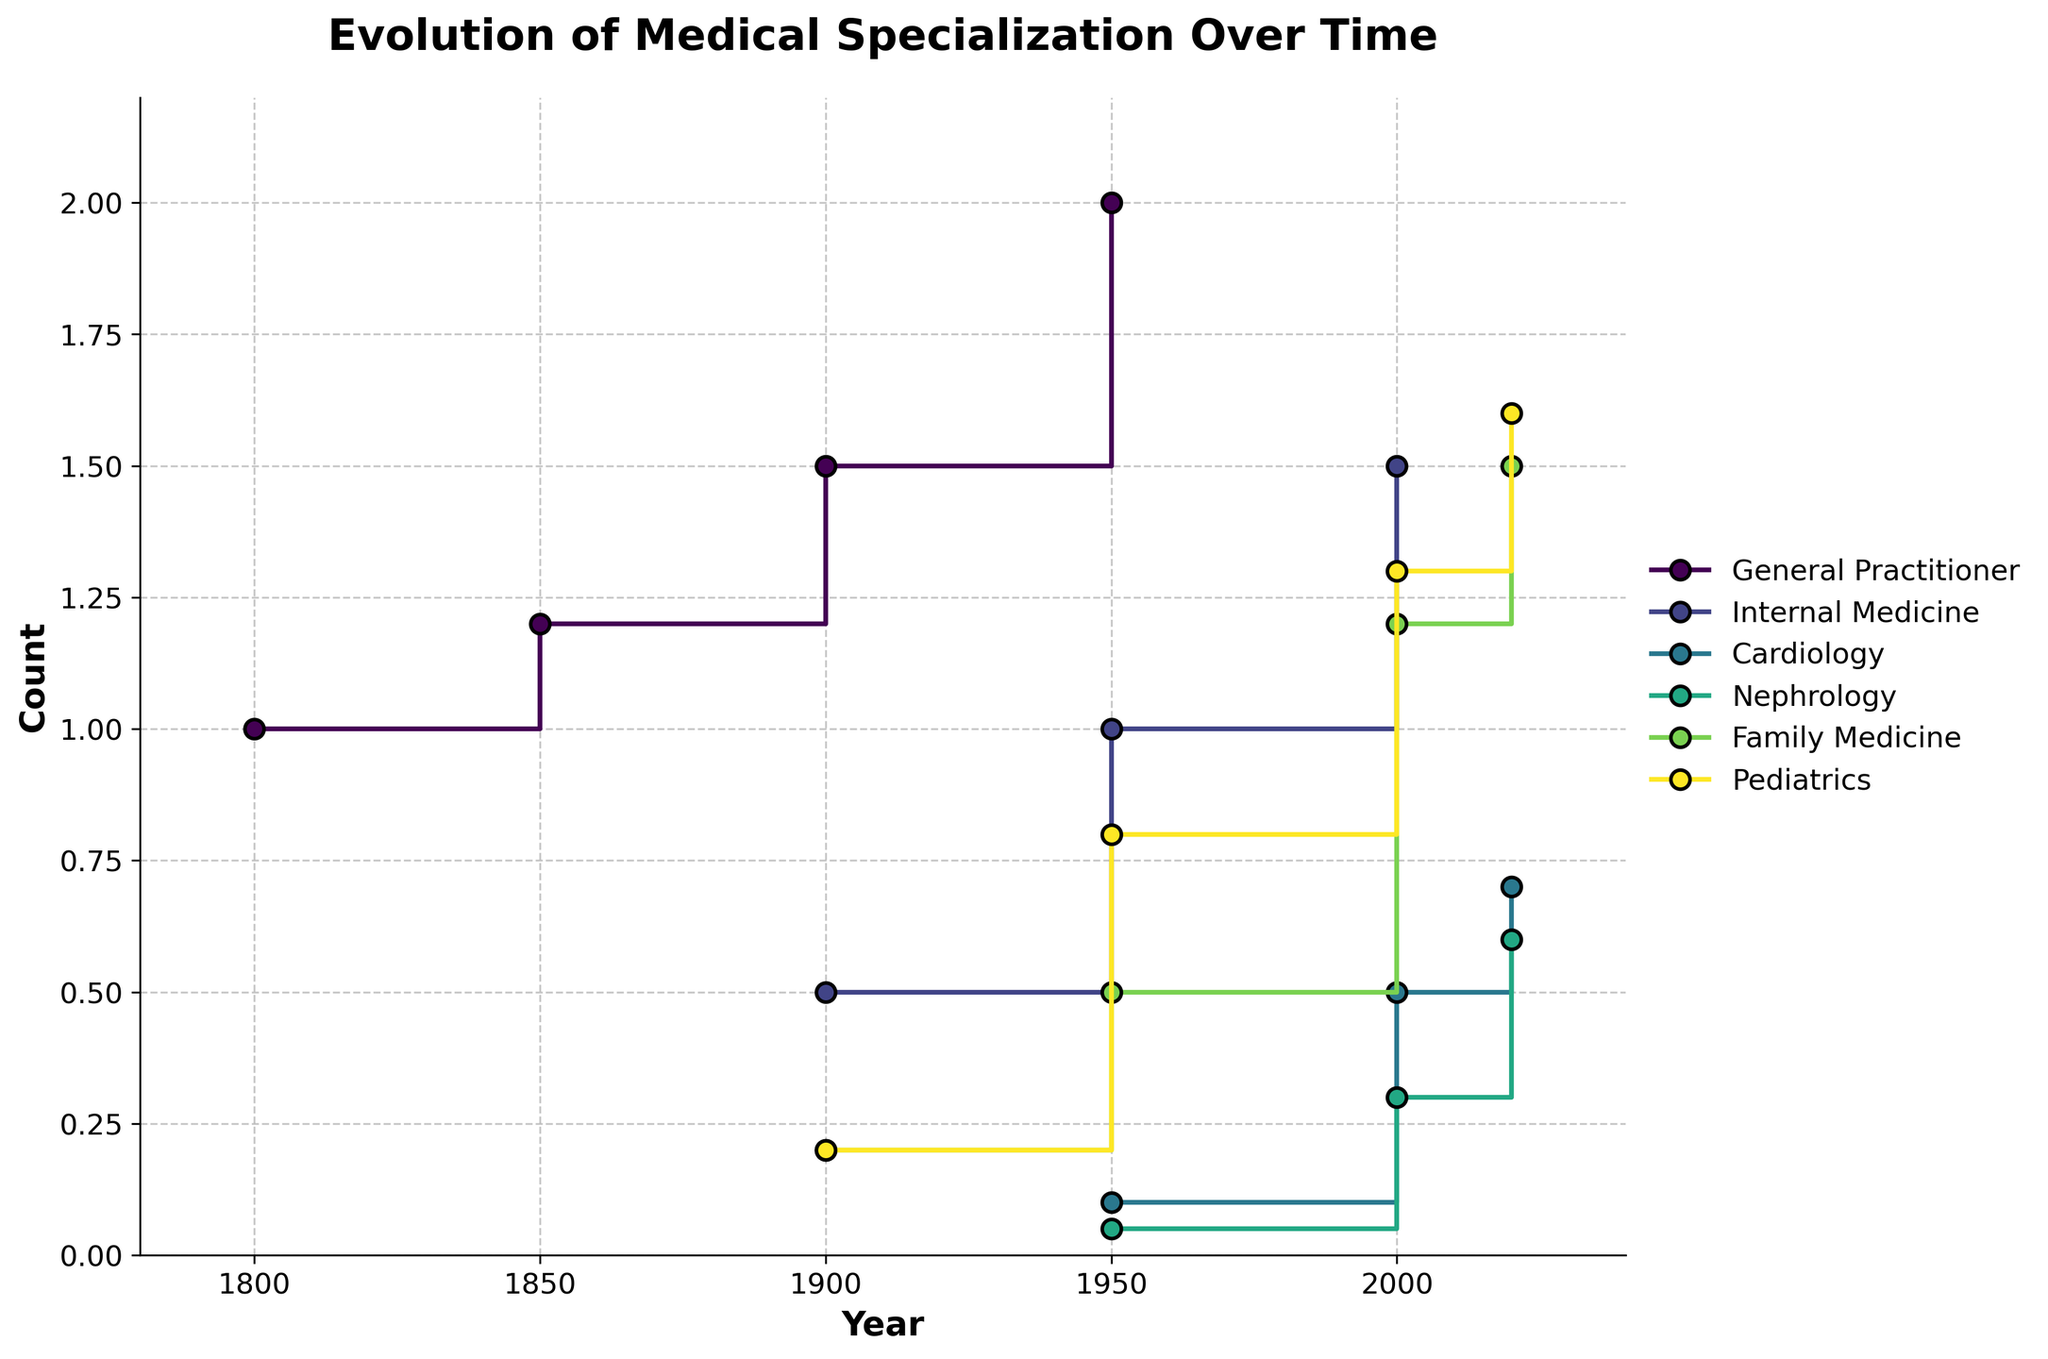What's the title of the figure? The title is usually the largest text at the top of the figure.
Answer: Evolution of Medical Specialization Over Time How many specializations are shown on the plot? Count the unique labels in the legend of the plot to determine the number of specializations.
Answer: 6 In what year did Internal Medicine reach a count of 1 for the first time? Look at the stair steps for Internal Medicine, focusing on when the count transitions to 1.
Answer: 1950 Which specialization had the highest count in the year 2020? Compare the final points of each stair step in the year 2020 to find the highest count.
Answer: Pediatrics What's the range of years represented on the x-axis? Identify the starting and ending values on the x-axis of the plot.
Answer: 1800 to 2020 In which year did Nephrology first appear in the data? Find the year associated with the first step for Nephrology.
Answer: 1950 Between which two consecutive years did Family Medicine see the largest increase in count? Observe the steplines for Family Medicine and compare the vertical differences between consecutive years.
Answer: 1950 to 2000 Which specialization consistently increased in count without any decreases over the years? Look at the step lines and observe which specialization always goes up.
Answer: Family Medicine Compare the count of Pediatrics in 1900 and 2020. By how much did it increase? Find the count of Pediatrics in both years and calculate the difference.
Answer: (1.6 - 0.2) = 1.4 How does the general trend of General Practitioners from 1800 to 1950 differ from that between 1950 and 2020? Evaluate the slope and changes in the General Practitioner stair steps across the two periods.
Answer: Steady increase from 1800 to 1950, plateau or slight changes afterward 